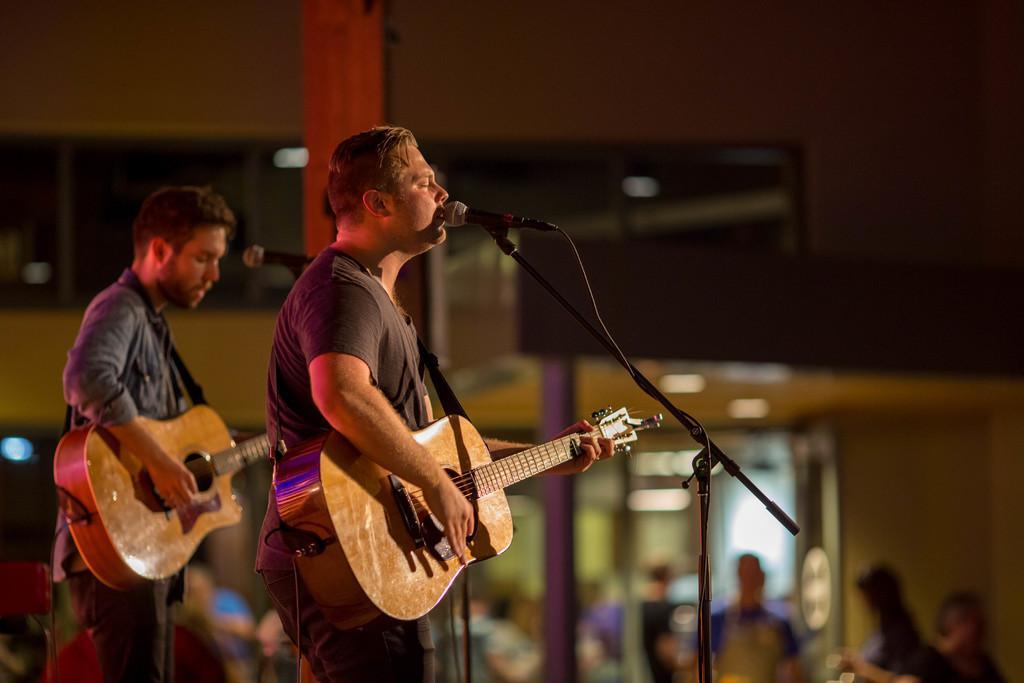How would you summarize this image in a sentence or two? These two persons are standing and playing guitar,this person singing. There are microphones with stands. On the background we can see wall,persons,pillar. 